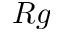<formula> <loc_0><loc_0><loc_500><loc_500>R g</formula> 